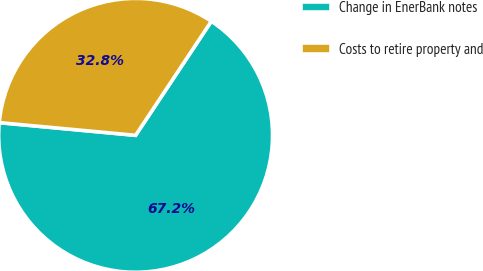Convert chart to OTSL. <chart><loc_0><loc_0><loc_500><loc_500><pie_chart><fcel>Change in EnerBank notes<fcel>Costs to retire property and<nl><fcel>67.15%<fcel>32.85%<nl></chart> 